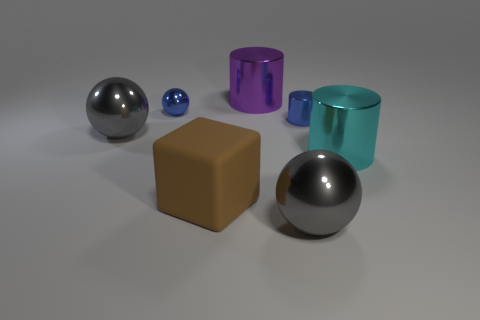Are there any big shiny cylinders behind the purple cylinder?
Make the answer very short. No. Is the number of purple shiny things to the right of the big cyan metal object the same as the number of purple cylinders?
Ensure brevity in your answer.  No. What size is the blue metal object that is the same shape as the cyan metal object?
Provide a succinct answer. Small. There is a big brown thing; does it have the same shape as the small metal object to the right of the small blue ball?
Offer a very short reply. No. There is a blue ball behind the gray object behind the large brown matte thing; what is its size?
Offer a terse response. Small. Is the number of tiny things that are to the left of the big brown rubber object the same as the number of spheres that are behind the blue metal cylinder?
Your answer should be compact. Yes. There is another large metallic thing that is the same shape as the large purple thing; what color is it?
Offer a terse response. Cyan. How many large spheres are the same color as the rubber cube?
Give a very brief answer. 0. There is a blue shiny object on the left side of the blue metal cylinder; is it the same shape as the matte thing?
Offer a terse response. No. What shape is the large shiny thing in front of the cylinder that is in front of the large gray object that is behind the big matte thing?
Provide a short and direct response. Sphere. 